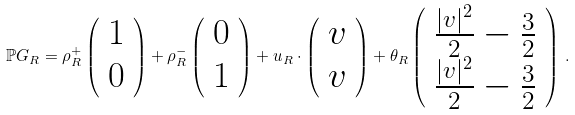Convert formula to latex. <formula><loc_0><loc_0><loc_500><loc_500>\mathbb { P } G _ { R } = \rho _ { R } ^ { + } \left ( \begin{array} { c } 1 \\ 0 \end{array} \right ) + \rho _ { R } ^ { - } \left ( \begin{array} { c } 0 \\ 1 \end{array} \right ) + u _ { R } \cdot \left ( \begin{array} { c } v \\ v \end{array} \right ) + \theta _ { R } \left ( \begin{array} { c } \frac { | v | ^ { 2 } } { 2 } - \frac { 3 } { 2 } \\ \frac { | v | ^ { 2 } } { 2 } - \frac { 3 } { 2 } \end{array} \right ) \, .</formula> 